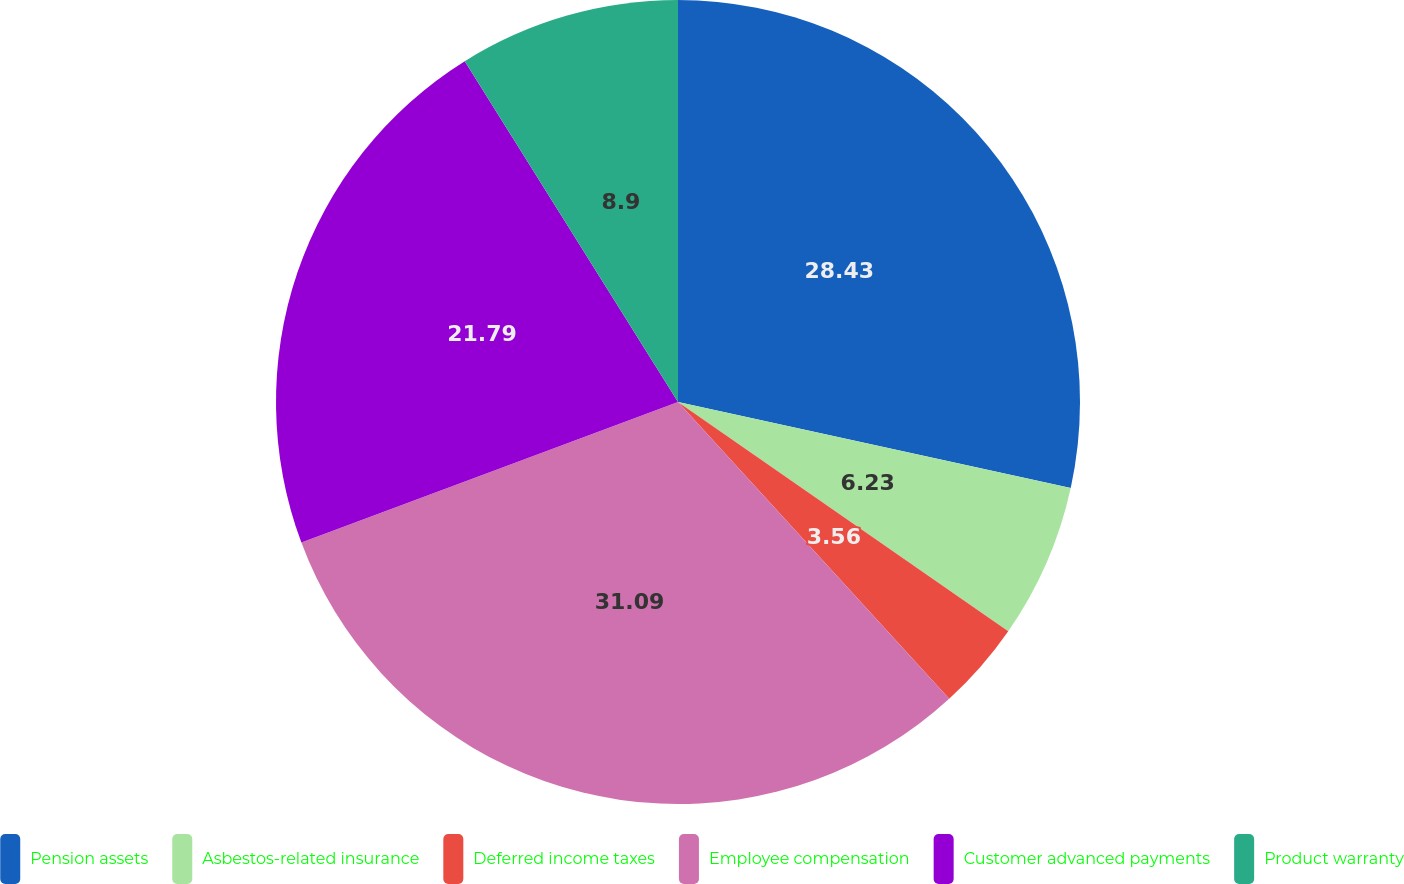Convert chart. <chart><loc_0><loc_0><loc_500><loc_500><pie_chart><fcel>Pension assets<fcel>Asbestos-related insurance<fcel>Deferred income taxes<fcel>Employee compensation<fcel>Customer advanced payments<fcel>Product warranty<nl><fcel>28.43%<fcel>6.23%<fcel>3.56%<fcel>31.1%<fcel>21.79%<fcel>8.9%<nl></chart> 